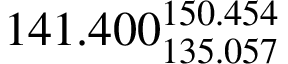Convert formula to latex. <formula><loc_0><loc_0><loc_500><loc_500>1 4 1 . 4 0 0 _ { 1 3 5 . 0 5 7 } ^ { 1 5 0 . 4 5 4 }</formula> 